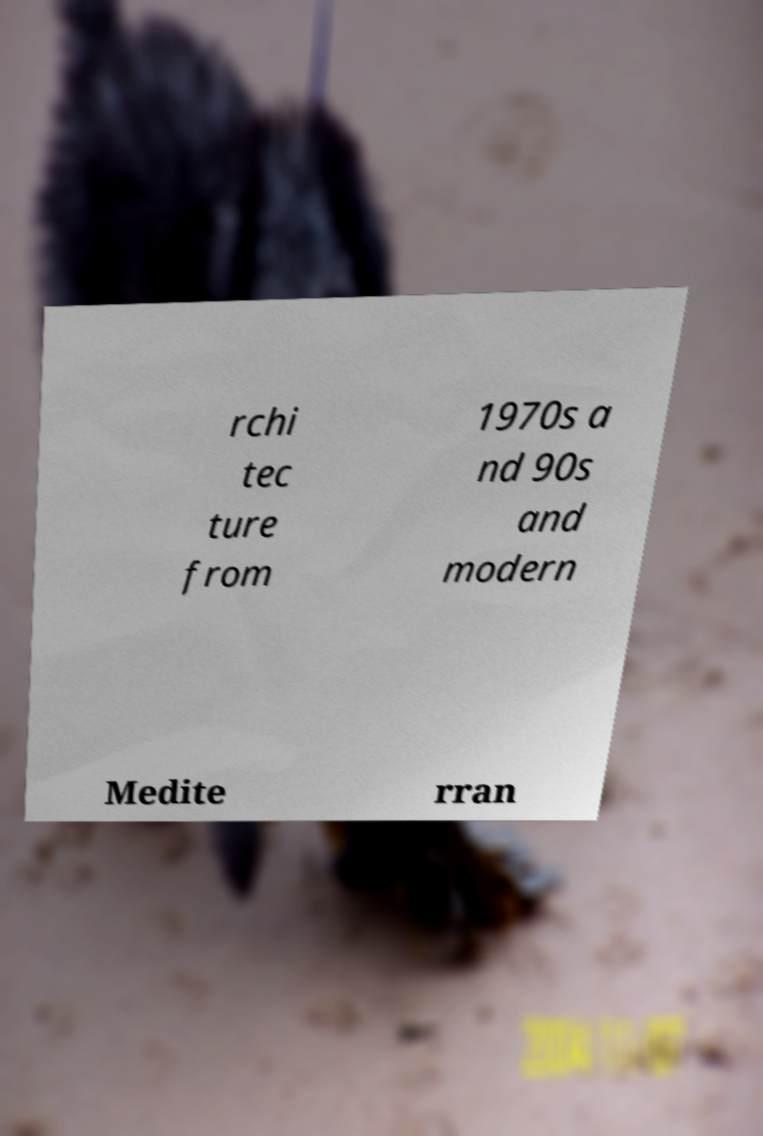For documentation purposes, I need the text within this image transcribed. Could you provide that? rchi tec ture from 1970s a nd 90s and modern Medite rran 